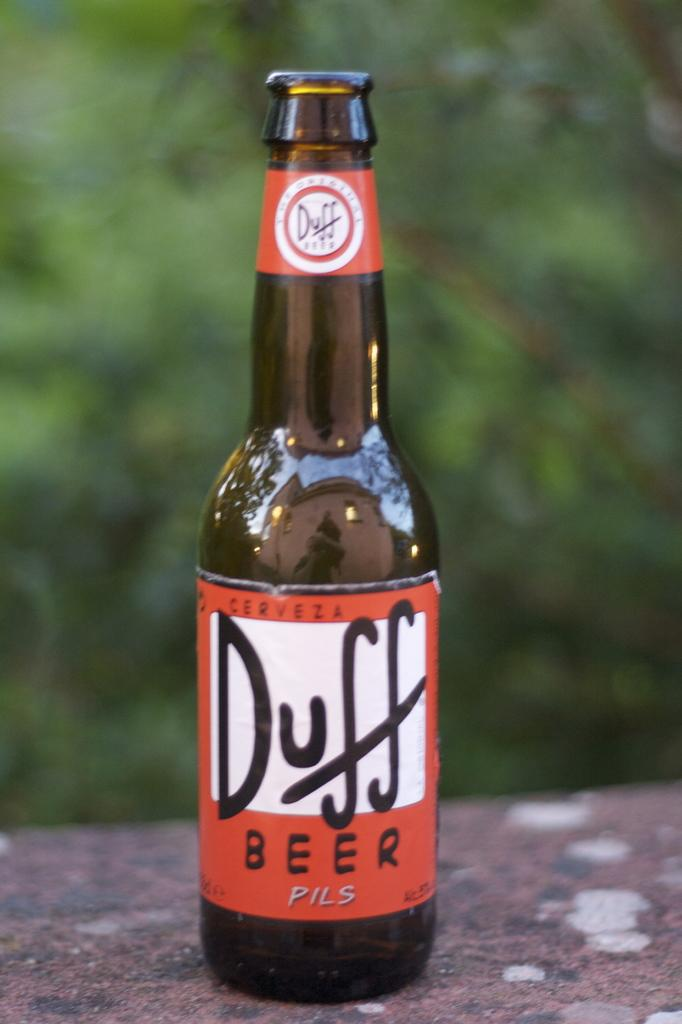<image>
Give a short and clear explanation of the subsequent image. The labels on Duff beer are orange, black, and white. 